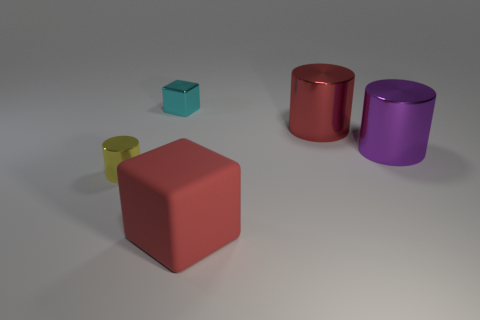Subtract all large metallic cylinders. How many cylinders are left? 1 Subtract all cylinders. How many objects are left? 2 Add 2 purple things. How many objects exist? 7 Subtract all purple cylinders. How many cylinders are left? 2 Add 5 big purple cylinders. How many big purple cylinders are left? 6 Add 3 small cyan metal things. How many small cyan metal things exist? 4 Subtract 1 red cubes. How many objects are left? 4 Subtract 1 blocks. How many blocks are left? 1 Subtract all red blocks. Subtract all yellow cylinders. How many blocks are left? 1 Subtract all green cylinders. How many red blocks are left? 1 